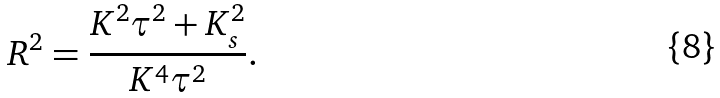<formula> <loc_0><loc_0><loc_500><loc_500>R ^ { 2 } = \frac { K ^ { 2 } \tau ^ { 2 } + K _ { s } ^ { 2 } } { K ^ { 4 } \tau ^ { 2 } } .</formula> 